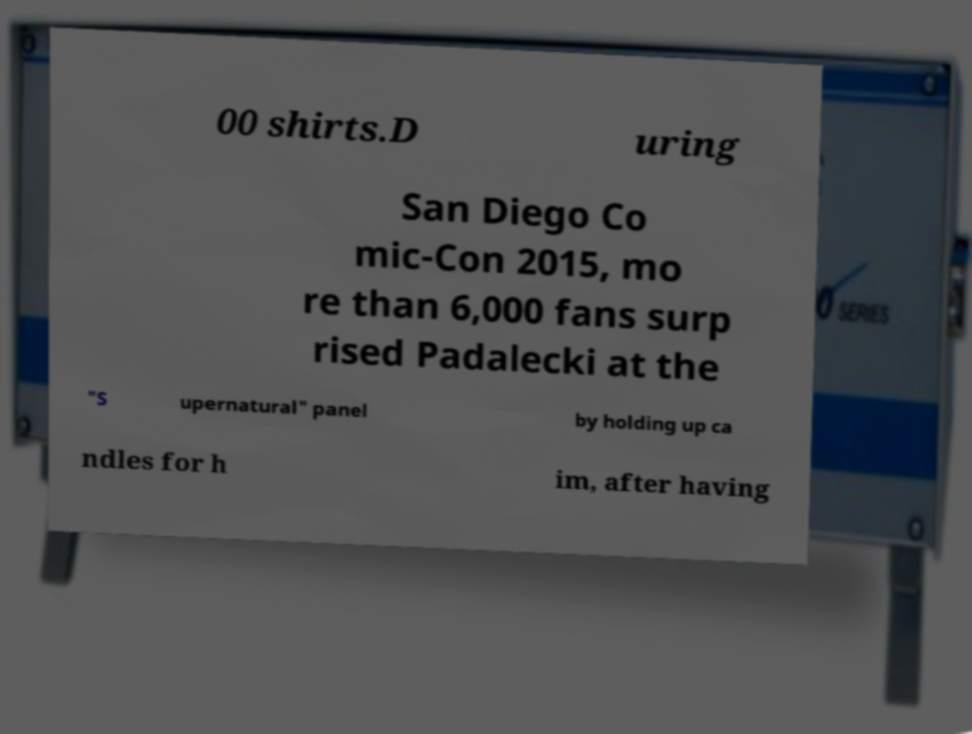For documentation purposes, I need the text within this image transcribed. Could you provide that? 00 shirts.D uring San Diego Co mic-Con 2015, mo re than 6,000 fans surp rised Padalecki at the "S upernatural" panel by holding up ca ndles for h im, after having 